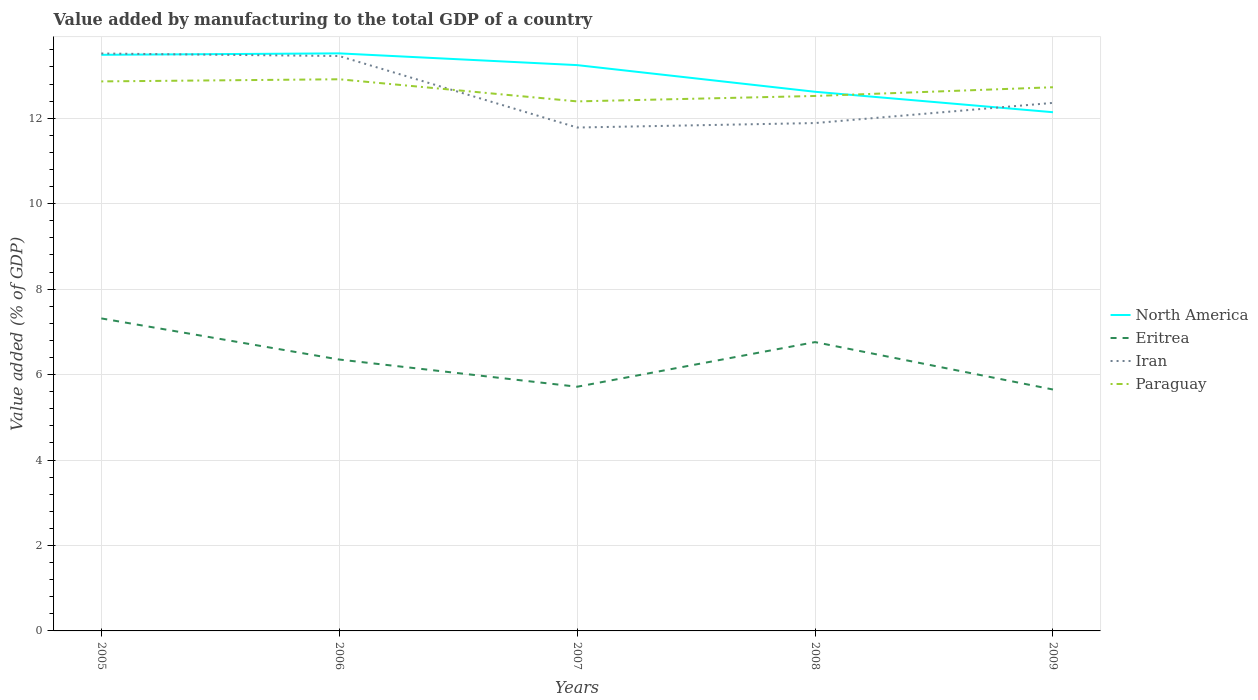Does the line corresponding to Eritrea intersect with the line corresponding to Paraguay?
Give a very brief answer. No. Across all years, what is the maximum value added by manufacturing to the total GDP in Iran?
Give a very brief answer. 11.78. What is the total value added by manufacturing to the total GDP in Eritrea in the graph?
Provide a short and direct response. -0.41. What is the difference between the highest and the second highest value added by manufacturing to the total GDP in Paraguay?
Provide a short and direct response. 0.52. What is the difference between the highest and the lowest value added by manufacturing to the total GDP in Iran?
Provide a short and direct response. 2. Is the value added by manufacturing to the total GDP in Iran strictly greater than the value added by manufacturing to the total GDP in Eritrea over the years?
Your response must be concise. No. How many years are there in the graph?
Give a very brief answer. 5. Are the values on the major ticks of Y-axis written in scientific E-notation?
Make the answer very short. No. Does the graph contain any zero values?
Ensure brevity in your answer.  No. Does the graph contain grids?
Offer a very short reply. Yes. Where does the legend appear in the graph?
Provide a short and direct response. Center right. How many legend labels are there?
Make the answer very short. 4. What is the title of the graph?
Offer a very short reply. Value added by manufacturing to the total GDP of a country. Does "Papua New Guinea" appear as one of the legend labels in the graph?
Your response must be concise. No. What is the label or title of the X-axis?
Your response must be concise. Years. What is the label or title of the Y-axis?
Your answer should be very brief. Value added (% of GDP). What is the Value added (% of GDP) of North America in 2005?
Give a very brief answer. 13.48. What is the Value added (% of GDP) of Eritrea in 2005?
Offer a terse response. 7.31. What is the Value added (% of GDP) in Iran in 2005?
Provide a succinct answer. 13.51. What is the Value added (% of GDP) of Paraguay in 2005?
Provide a succinct answer. 12.86. What is the Value added (% of GDP) of North America in 2006?
Keep it short and to the point. 13.52. What is the Value added (% of GDP) of Eritrea in 2006?
Make the answer very short. 6.35. What is the Value added (% of GDP) of Iran in 2006?
Your answer should be compact. 13.45. What is the Value added (% of GDP) of Paraguay in 2006?
Your answer should be very brief. 12.91. What is the Value added (% of GDP) of North America in 2007?
Offer a terse response. 13.24. What is the Value added (% of GDP) of Eritrea in 2007?
Keep it short and to the point. 5.71. What is the Value added (% of GDP) of Iran in 2007?
Your answer should be compact. 11.78. What is the Value added (% of GDP) in Paraguay in 2007?
Your answer should be very brief. 12.39. What is the Value added (% of GDP) of North America in 2008?
Provide a short and direct response. 12.62. What is the Value added (% of GDP) in Eritrea in 2008?
Keep it short and to the point. 6.76. What is the Value added (% of GDP) of Iran in 2008?
Provide a succinct answer. 11.89. What is the Value added (% of GDP) in Paraguay in 2008?
Keep it short and to the point. 12.52. What is the Value added (% of GDP) in North America in 2009?
Offer a terse response. 12.14. What is the Value added (% of GDP) of Eritrea in 2009?
Provide a succinct answer. 5.65. What is the Value added (% of GDP) in Iran in 2009?
Give a very brief answer. 12.36. What is the Value added (% of GDP) of Paraguay in 2009?
Offer a terse response. 12.72. Across all years, what is the maximum Value added (% of GDP) in North America?
Your answer should be very brief. 13.52. Across all years, what is the maximum Value added (% of GDP) of Eritrea?
Your answer should be very brief. 7.31. Across all years, what is the maximum Value added (% of GDP) of Iran?
Your answer should be very brief. 13.51. Across all years, what is the maximum Value added (% of GDP) of Paraguay?
Keep it short and to the point. 12.91. Across all years, what is the minimum Value added (% of GDP) in North America?
Your answer should be compact. 12.14. Across all years, what is the minimum Value added (% of GDP) of Eritrea?
Your response must be concise. 5.65. Across all years, what is the minimum Value added (% of GDP) of Iran?
Ensure brevity in your answer.  11.78. Across all years, what is the minimum Value added (% of GDP) in Paraguay?
Provide a succinct answer. 12.39. What is the total Value added (% of GDP) in North America in the graph?
Make the answer very short. 65. What is the total Value added (% of GDP) of Eritrea in the graph?
Provide a succinct answer. 31.79. What is the total Value added (% of GDP) in Iran in the graph?
Offer a very short reply. 63. What is the total Value added (% of GDP) in Paraguay in the graph?
Your answer should be very brief. 63.41. What is the difference between the Value added (% of GDP) in North America in 2005 and that in 2006?
Provide a succinct answer. -0.03. What is the difference between the Value added (% of GDP) in Eritrea in 2005 and that in 2006?
Keep it short and to the point. 0.96. What is the difference between the Value added (% of GDP) of Iran in 2005 and that in 2006?
Provide a short and direct response. 0.06. What is the difference between the Value added (% of GDP) in North America in 2005 and that in 2007?
Make the answer very short. 0.24. What is the difference between the Value added (% of GDP) in Eritrea in 2005 and that in 2007?
Offer a terse response. 1.6. What is the difference between the Value added (% of GDP) of Iran in 2005 and that in 2007?
Ensure brevity in your answer.  1.73. What is the difference between the Value added (% of GDP) of Paraguay in 2005 and that in 2007?
Your answer should be very brief. 0.47. What is the difference between the Value added (% of GDP) in North America in 2005 and that in 2008?
Make the answer very short. 0.87. What is the difference between the Value added (% of GDP) in Eritrea in 2005 and that in 2008?
Provide a succinct answer. 0.55. What is the difference between the Value added (% of GDP) in Iran in 2005 and that in 2008?
Provide a short and direct response. 1.63. What is the difference between the Value added (% of GDP) in Paraguay in 2005 and that in 2008?
Make the answer very short. 0.34. What is the difference between the Value added (% of GDP) in North America in 2005 and that in 2009?
Make the answer very short. 1.34. What is the difference between the Value added (% of GDP) of Eritrea in 2005 and that in 2009?
Ensure brevity in your answer.  1.66. What is the difference between the Value added (% of GDP) of Iran in 2005 and that in 2009?
Provide a succinct answer. 1.16. What is the difference between the Value added (% of GDP) in Paraguay in 2005 and that in 2009?
Your answer should be very brief. 0.14. What is the difference between the Value added (% of GDP) of North America in 2006 and that in 2007?
Keep it short and to the point. 0.27. What is the difference between the Value added (% of GDP) of Eritrea in 2006 and that in 2007?
Your response must be concise. 0.64. What is the difference between the Value added (% of GDP) in Iran in 2006 and that in 2007?
Give a very brief answer. 1.67. What is the difference between the Value added (% of GDP) in Paraguay in 2006 and that in 2007?
Your response must be concise. 0.52. What is the difference between the Value added (% of GDP) in North America in 2006 and that in 2008?
Give a very brief answer. 0.9. What is the difference between the Value added (% of GDP) of Eritrea in 2006 and that in 2008?
Your answer should be compact. -0.41. What is the difference between the Value added (% of GDP) of Iran in 2006 and that in 2008?
Your response must be concise. 1.57. What is the difference between the Value added (% of GDP) of Paraguay in 2006 and that in 2008?
Keep it short and to the point. 0.39. What is the difference between the Value added (% of GDP) in North America in 2006 and that in 2009?
Provide a succinct answer. 1.38. What is the difference between the Value added (% of GDP) in Eritrea in 2006 and that in 2009?
Provide a short and direct response. 0.7. What is the difference between the Value added (% of GDP) in Iran in 2006 and that in 2009?
Provide a short and direct response. 1.1. What is the difference between the Value added (% of GDP) in Paraguay in 2006 and that in 2009?
Offer a terse response. 0.19. What is the difference between the Value added (% of GDP) in North America in 2007 and that in 2008?
Provide a succinct answer. 0.62. What is the difference between the Value added (% of GDP) of Eritrea in 2007 and that in 2008?
Ensure brevity in your answer.  -1.04. What is the difference between the Value added (% of GDP) of Iran in 2007 and that in 2008?
Keep it short and to the point. -0.1. What is the difference between the Value added (% of GDP) in Paraguay in 2007 and that in 2008?
Offer a very short reply. -0.13. What is the difference between the Value added (% of GDP) of North America in 2007 and that in 2009?
Your response must be concise. 1.1. What is the difference between the Value added (% of GDP) in Eritrea in 2007 and that in 2009?
Your response must be concise. 0.06. What is the difference between the Value added (% of GDP) in Iran in 2007 and that in 2009?
Your response must be concise. -0.58. What is the difference between the Value added (% of GDP) in Paraguay in 2007 and that in 2009?
Your answer should be compact. -0.33. What is the difference between the Value added (% of GDP) in North America in 2008 and that in 2009?
Provide a succinct answer. 0.48. What is the difference between the Value added (% of GDP) in Eritrea in 2008 and that in 2009?
Provide a short and direct response. 1.11. What is the difference between the Value added (% of GDP) of Iran in 2008 and that in 2009?
Provide a short and direct response. -0.47. What is the difference between the Value added (% of GDP) of Paraguay in 2008 and that in 2009?
Keep it short and to the point. -0.2. What is the difference between the Value added (% of GDP) of North America in 2005 and the Value added (% of GDP) of Eritrea in 2006?
Provide a succinct answer. 7.13. What is the difference between the Value added (% of GDP) in North America in 2005 and the Value added (% of GDP) in Iran in 2006?
Provide a succinct answer. 0.03. What is the difference between the Value added (% of GDP) of North America in 2005 and the Value added (% of GDP) of Paraguay in 2006?
Offer a very short reply. 0.57. What is the difference between the Value added (% of GDP) in Eritrea in 2005 and the Value added (% of GDP) in Iran in 2006?
Your answer should be compact. -6.14. What is the difference between the Value added (% of GDP) in Eritrea in 2005 and the Value added (% of GDP) in Paraguay in 2006?
Make the answer very short. -5.6. What is the difference between the Value added (% of GDP) in Iran in 2005 and the Value added (% of GDP) in Paraguay in 2006?
Offer a very short reply. 0.6. What is the difference between the Value added (% of GDP) of North America in 2005 and the Value added (% of GDP) of Eritrea in 2007?
Provide a succinct answer. 7.77. What is the difference between the Value added (% of GDP) of North America in 2005 and the Value added (% of GDP) of Iran in 2007?
Offer a terse response. 1.7. What is the difference between the Value added (% of GDP) of North America in 2005 and the Value added (% of GDP) of Paraguay in 2007?
Your answer should be compact. 1.09. What is the difference between the Value added (% of GDP) of Eritrea in 2005 and the Value added (% of GDP) of Iran in 2007?
Give a very brief answer. -4.47. What is the difference between the Value added (% of GDP) in Eritrea in 2005 and the Value added (% of GDP) in Paraguay in 2007?
Offer a very short reply. -5.08. What is the difference between the Value added (% of GDP) of Iran in 2005 and the Value added (% of GDP) of Paraguay in 2007?
Your response must be concise. 1.12. What is the difference between the Value added (% of GDP) of North America in 2005 and the Value added (% of GDP) of Eritrea in 2008?
Make the answer very short. 6.72. What is the difference between the Value added (% of GDP) in North America in 2005 and the Value added (% of GDP) in Iran in 2008?
Provide a short and direct response. 1.6. What is the difference between the Value added (% of GDP) in North America in 2005 and the Value added (% of GDP) in Paraguay in 2008?
Your answer should be compact. 0.96. What is the difference between the Value added (% of GDP) in Eritrea in 2005 and the Value added (% of GDP) in Iran in 2008?
Provide a short and direct response. -4.57. What is the difference between the Value added (% of GDP) of Eritrea in 2005 and the Value added (% of GDP) of Paraguay in 2008?
Offer a terse response. -5.21. What is the difference between the Value added (% of GDP) in North America in 2005 and the Value added (% of GDP) in Eritrea in 2009?
Your answer should be compact. 7.83. What is the difference between the Value added (% of GDP) in North America in 2005 and the Value added (% of GDP) in Iran in 2009?
Provide a short and direct response. 1.13. What is the difference between the Value added (% of GDP) in North America in 2005 and the Value added (% of GDP) in Paraguay in 2009?
Provide a short and direct response. 0.76. What is the difference between the Value added (% of GDP) of Eritrea in 2005 and the Value added (% of GDP) of Iran in 2009?
Make the answer very short. -5.04. What is the difference between the Value added (% of GDP) in Eritrea in 2005 and the Value added (% of GDP) in Paraguay in 2009?
Keep it short and to the point. -5.41. What is the difference between the Value added (% of GDP) in Iran in 2005 and the Value added (% of GDP) in Paraguay in 2009?
Ensure brevity in your answer.  0.79. What is the difference between the Value added (% of GDP) in North America in 2006 and the Value added (% of GDP) in Eritrea in 2007?
Keep it short and to the point. 7.8. What is the difference between the Value added (% of GDP) of North America in 2006 and the Value added (% of GDP) of Iran in 2007?
Your response must be concise. 1.74. What is the difference between the Value added (% of GDP) in North America in 2006 and the Value added (% of GDP) in Paraguay in 2007?
Provide a short and direct response. 1.12. What is the difference between the Value added (% of GDP) of Eritrea in 2006 and the Value added (% of GDP) of Iran in 2007?
Keep it short and to the point. -5.43. What is the difference between the Value added (% of GDP) of Eritrea in 2006 and the Value added (% of GDP) of Paraguay in 2007?
Your answer should be compact. -6.04. What is the difference between the Value added (% of GDP) of Iran in 2006 and the Value added (% of GDP) of Paraguay in 2007?
Provide a succinct answer. 1.06. What is the difference between the Value added (% of GDP) in North America in 2006 and the Value added (% of GDP) in Eritrea in 2008?
Your answer should be compact. 6.76. What is the difference between the Value added (% of GDP) of North America in 2006 and the Value added (% of GDP) of Iran in 2008?
Make the answer very short. 1.63. What is the difference between the Value added (% of GDP) in North America in 2006 and the Value added (% of GDP) in Paraguay in 2008?
Keep it short and to the point. 1. What is the difference between the Value added (% of GDP) of Eritrea in 2006 and the Value added (% of GDP) of Iran in 2008?
Make the answer very short. -5.53. What is the difference between the Value added (% of GDP) in Eritrea in 2006 and the Value added (% of GDP) in Paraguay in 2008?
Give a very brief answer. -6.17. What is the difference between the Value added (% of GDP) of Iran in 2006 and the Value added (% of GDP) of Paraguay in 2008?
Provide a succinct answer. 0.93. What is the difference between the Value added (% of GDP) in North America in 2006 and the Value added (% of GDP) in Eritrea in 2009?
Your answer should be very brief. 7.87. What is the difference between the Value added (% of GDP) in North America in 2006 and the Value added (% of GDP) in Iran in 2009?
Make the answer very short. 1.16. What is the difference between the Value added (% of GDP) in North America in 2006 and the Value added (% of GDP) in Paraguay in 2009?
Make the answer very short. 0.79. What is the difference between the Value added (% of GDP) in Eritrea in 2006 and the Value added (% of GDP) in Iran in 2009?
Offer a terse response. -6.01. What is the difference between the Value added (% of GDP) of Eritrea in 2006 and the Value added (% of GDP) of Paraguay in 2009?
Keep it short and to the point. -6.37. What is the difference between the Value added (% of GDP) of Iran in 2006 and the Value added (% of GDP) of Paraguay in 2009?
Your answer should be compact. 0.73. What is the difference between the Value added (% of GDP) of North America in 2007 and the Value added (% of GDP) of Eritrea in 2008?
Your response must be concise. 6.48. What is the difference between the Value added (% of GDP) in North America in 2007 and the Value added (% of GDP) in Iran in 2008?
Your answer should be very brief. 1.36. What is the difference between the Value added (% of GDP) in North America in 2007 and the Value added (% of GDP) in Paraguay in 2008?
Your answer should be compact. 0.72. What is the difference between the Value added (% of GDP) in Eritrea in 2007 and the Value added (% of GDP) in Iran in 2008?
Provide a short and direct response. -6.17. What is the difference between the Value added (% of GDP) of Eritrea in 2007 and the Value added (% of GDP) of Paraguay in 2008?
Give a very brief answer. -6.81. What is the difference between the Value added (% of GDP) of Iran in 2007 and the Value added (% of GDP) of Paraguay in 2008?
Your response must be concise. -0.74. What is the difference between the Value added (% of GDP) of North America in 2007 and the Value added (% of GDP) of Eritrea in 2009?
Your answer should be compact. 7.59. What is the difference between the Value added (% of GDP) in North America in 2007 and the Value added (% of GDP) in Iran in 2009?
Keep it short and to the point. 0.88. What is the difference between the Value added (% of GDP) in North America in 2007 and the Value added (% of GDP) in Paraguay in 2009?
Your response must be concise. 0.52. What is the difference between the Value added (% of GDP) of Eritrea in 2007 and the Value added (% of GDP) of Iran in 2009?
Your answer should be very brief. -6.64. What is the difference between the Value added (% of GDP) of Eritrea in 2007 and the Value added (% of GDP) of Paraguay in 2009?
Make the answer very short. -7.01. What is the difference between the Value added (% of GDP) of Iran in 2007 and the Value added (% of GDP) of Paraguay in 2009?
Your response must be concise. -0.94. What is the difference between the Value added (% of GDP) in North America in 2008 and the Value added (% of GDP) in Eritrea in 2009?
Provide a short and direct response. 6.97. What is the difference between the Value added (% of GDP) of North America in 2008 and the Value added (% of GDP) of Iran in 2009?
Make the answer very short. 0.26. What is the difference between the Value added (% of GDP) of North America in 2008 and the Value added (% of GDP) of Paraguay in 2009?
Provide a succinct answer. -0.11. What is the difference between the Value added (% of GDP) of Eritrea in 2008 and the Value added (% of GDP) of Iran in 2009?
Your response must be concise. -5.6. What is the difference between the Value added (% of GDP) in Eritrea in 2008 and the Value added (% of GDP) in Paraguay in 2009?
Offer a very short reply. -5.96. What is the difference between the Value added (% of GDP) in Iran in 2008 and the Value added (% of GDP) in Paraguay in 2009?
Your answer should be compact. -0.84. What is the average Value added (% of GDP) of North America per year?
Keep it short and to the point. 13. What is the average Value added (% of GDP) in Eritrea per year?
Make the answer very short. 6.36. What is the average Value added (% of GDP) of Iran per year?
Make the answer very short. 12.6. What is the average Value added (% of GDP) in Paraguay per year?
Offer a terse response. 12.68. In the year 2005, what is the difference between the Value added (% of GDP) in North America and Value added (% of GDP) in Eritrea?
Offer a very short reply. 6.17. In the year 2005, what is the difference between the Value added (% of GDP) of North America and Value added (% of GDP) of Iran?
Your answer should be very brief. -0.03. In the year 2005, what is the difference between the Value added (% of GDP) in North America and Value added (% of GDP) in Paraguay?
Ensure brevity in your answer.  0.62. In the year 2005, what is the difference between the Value added (% of GDP) of Eritrea and Value added (% of GDP) of Iran?
Your answer should be compact. -6.2. In the year 2005, what is the difference between the Value added (% of GDP) of Eritrea and Value added (% of GDP) of Paraguay?
Give a very brief answer. -5.55. In the year 2005, what is the difference between the Value added (% of GDP) of Iran and Value added (% of GDP) of Paraguay?
Your response must be concise. 0.65. In the year 2006, what is the difference between the Value added (% of GDP) in North America and Value added (% of GDP) in Eritrea?
Your response must be concise. 7.17. In the year 2006, what is the difference between the Value added (% of GDP) in North America and Value added (% of GDP) in Iran?
Keep it short and to the point. 0.06. In the year 2006, what is the difference between the Value added (% of GDP) of North America and Value added (% of GDP) of Paraguay?
Keep it short and to the point. 0.61. In the year 2006, what is the difference between the Value added (% of GDP) in Eritrea and Value added (% of GDP) in Iran?
Your answer should be very brief. -7.1. In the year 2006, what is the difference between the Value added (% of GDP) of Eritrea and Value added (% of GDP) of Paraguay?
Ensure brevity in your answer.  -6.56. In the year 2006, what is the difference between the Value added (% of GDP) in Iran and Value added (% of GDP) in Paraguay?
Ensure brevity in your answer.  0.54. In the year 2007, what is the difference between the Value added (% of GDP) of North America and Value added (% of GDP) of Eritrea?
Your answer should be compact. 7.53. In the year 2007, what is the difference between the Value added (% of GDP) in North America and Value added (% of GDP) in Iran?
Give a very brief answer. 1.46. In the year 2007, what is the difference between the Value added (% of GDP) of North America and Value added (% of GDP) of Paraguay?
Make the answer very short. 0.85. In the year 2007, what is the difference between the Value added (% of GDP) in Eritrea and Value added (% of GDP) in Iran?
Provide a short and direct response. -6.07. In the year 2007, what is the difference between the Value added (% of GDP) of Eritrea and Value added (% of GDP) of Paraguay?
Keep it short and to the point. -6.68. In the year 2007, what is the difference between the Value added (% of GDP) of Iran and Value added (% of GDP) of Paraguay?
Provide a short and direct response. -0.61. In the year 2008, what is the difference between the Value added (% of GDP) in North America and Value added (% of GDP) in Eritrea?
Keep it short and to the point. 5.86. In the year 2008, what is the difference between the Value added (% of GDP) of North America and Value added (% of GDP) of Iran?
Provide a short and direct response. 0.73. In the year 2008, what is the difference between the Value added (% of GDP) in North America and Value added (% of GDP) in Paraguay?
Your answer should be very brief. 0.1. In the year 2008, what is the difference between the Value added (% of GDP) in Eritrea and Value added (% of GDP) in Iran?
Make the answer very short. -5.13. In the year 2008, what is the difference between the Value added (% of GDP) of Eritrea and Value added (% of GDP) of Paraguay?
Your response must be concise. -5.76. In the year 2008, what is the difference between the Value added (% of GDP) of Iran and Value added (% of GDP) of Paraguay?
Your response must be concise. -0.63. In the year 2009, what is the difference between the Value added (% of GDP) of North America and Value added (% of GDP) of Eritrea?
Provide a succinct answer. 6.49. In the year 2009, what is the difference between the Value added (% of GDP) in North America and Value added (% of GDP) in Iran?
Provide a short and direct response. -0.22. In the year 2009, what is the difference between the Value added (% of GDP) in North America and Value added (% of GDP) in Paraguay?
Make the answer very short. -0.58. In the year 2009, what is the difference between the Value added (% of GDP) in Eritrea and Value added (% of GDP) in Iran?
Offer a terse response. -6.71. In the year 2009, what is the difference between the Value added (% of GDP) of Eritrea and Value added (% of GDP) of Paraguay?
Offer a terse response. -7.07. In the year 2009, what is the difference between the Value added (% of GDP) in Iran and Value added (% of GDP) in Paraguay?
Make the answer very short. -0.37. What is the ratio of the Value added (% of GDP) of North America in 2005 to that in 2006?
Offer a very short reply. 1. What is the ratio of the Value added (% of GDP) in Eritrea in 2005 to that in 2006?
Your answer should be compact. 1.15. What is the ratio of the Value added (% of GDP) in North America in 2005 to that in 2007?
Provide a succinct answer. 1.02. What is the ratio of the Value added (% of GDP) of Eritrea in 2005 to that in 2007?
Offer a terse response. 1.28. What is the ratio of the Value added (% of GDP) in Iran in 2005 to that in 2007?
Provide a short and direct response. 1.15. What is the ratio of the Value added (% of GDP) of Paraguay in 2005 to that in 2007?
Keep it short and to the point. 1.04. What is the ratio of the Value added (% of GDP) in North America in 2005 to that in 2008?
Provide a short and direct response. 1.07. What is the ratio of the Value added (% of GDP) in Eritrea in 2005 to that in 2008?
Your answer should be very brief. 1.08. What is the ratio of the Value added (% of GDP) in Iran in 2005 to that in 2008?
Make the answer very short. 1.14. What is the ratio of the Value added (% of GDP) in Paraguay in 2005 to that in 2008?
Ensure brevity in your answer.  1.03. What is the ratio of the Value added (% of GDP) in North America in 2005 to that in 2009?
Provide a succinct answer. 1.11. What is the ratio of the Value added (% of GDP) of Eritrea in 2005 to that in 2009?
Give a very brief answer. 1.29. What is the ratio of the Value added (% of GDP) in Iran in 2005 to that in 2009?
Give a very brief answer. 1.09. What is the ratio of the Value added (% of GDP) of Paraguay in 2005 to that in 2009?
Your response must be concise. 1.01. What is the ratio of the Value added (% of GDP) in North America in 2006 to that in 2007?
Provide a succinct answer. 1.02. What is the ratio of the Value added (% of GDP) of Eritrea in 2006 to that in 2007?
Keep it short and to the point. 1.11. What is the ratio of the Value added (% of GDP) in Iran in 2006 to that in 2007?
Your answer should be compact. 1.14. What is the ratio of the Value added (% of GDP) in Paraguay in 2006 to that in 2007?
Your response must be concise. 1.04. What is the ratio of the Value added (% of GDP) of North America in 2006 to that in 2008?
Your answer should be compact. 1.07. What is the ratio of the Value added (% of GDP) in Eritrea in 2006 to that in 2008?
Give a very brief answer. 0.94. What is the ratio of the Value added (% of GDP) in Iran in 2006 to that in 2008?
Your response must be concise. 1.13. What is the ratio of the Value added (% of GDP) in Paraguay in 2006 to that in 2008?
Offer a terse response. 1.03. What is the ratio of the Value added (% of GDP) of North America in 2006 to that in 2009?
Your answer should be compact. 1.11. What is the ratio of the Value added (% of GDP) of Eritrea in 2006 to that in 2009?
Provide a short and direct response. 1.12. What is the ratio of the Value added (% of GDP) in Iran in 2006 to that in 2009?
Offer a very short reply. 1.09. What is the ratio of the Value added (% of GDP) in Paraguay in 2006 to that in 2009?
Your answer should be compact. 1.01. What is the ratio of the Value added (% of GDP) in North America in 2007 to that in 2008?
Provide a short and direct response. 1.05. What is the ratio of the Value added (% of GDP) in Eritrea in 2007 to that in 2008?
Make the answer very short. 0.85. What is the ratio of the Value added (% of GDP) in Paraguay in 2007 to that in 2008?
Keep it short and to the point. 0.99. What is the ratio of the Value added (% of GDP) of North America in 2007 to that in 2009?
Give a very brief answer. 1.09. What is the ratio of the Value added (% of GDP) of Eritrea in 2007 to that in 2009?
Your answer should be compact. 1.01. What is the ratio of the Value added (% of GDP) of Iran in 2007 to that in 2009?
Keep it short and to the point. 0.95. What is the ratio of the Value added (% of GDP) of Paraguay in 2007 to that in 2009?
Ensure brevity in your answer.  0.97. What is the ratio of the Value added (% of GDP) in North America in 2008 to that in 2009?
Make the answer very short. 1.04. What is the ratio of the Value added (% of GDP) in Eritrea in 2008 to that in 2009?
Make the answer very short. 1.2. What is the ratio of the Value added (% of GDP) of Iran in 2008 to that in 2009?
Your answer should be very brief. 0.96. What is the ratio of the Value added (% of GDP) in Paraguay in 2008 to that in 2009?
Offer a very short reply. 0.98. What is the difference between the highest and the second highest Value added (% of GDP) of North America?
Your response must be concise. 0.03. What is the difference between the highest and the second highest Value added (% of GDP) of Eritrea?
Provide a short and direct response. 0.55. What is the difference between the highest and the second highest Value added (% of GDP) of Iran?
Offer a very short reply. 0.06. What is the difference between the highest and the lowest Value added (% of GDP) of North America?
Your answer should be compact. 1.38. What is the difference between the highest and the lowest Value added (% of GDP) in Eritrea?
Provide a short and direct response. 1.66. What is the difference between the highest and the lowest Value added (% of GDP) in Iran?
Give a very brief answer. 1.73. What is the difference between the highest and the lowest Value added (% of GDP) in Paraguay?
Your answer should be compact. 0.52. 